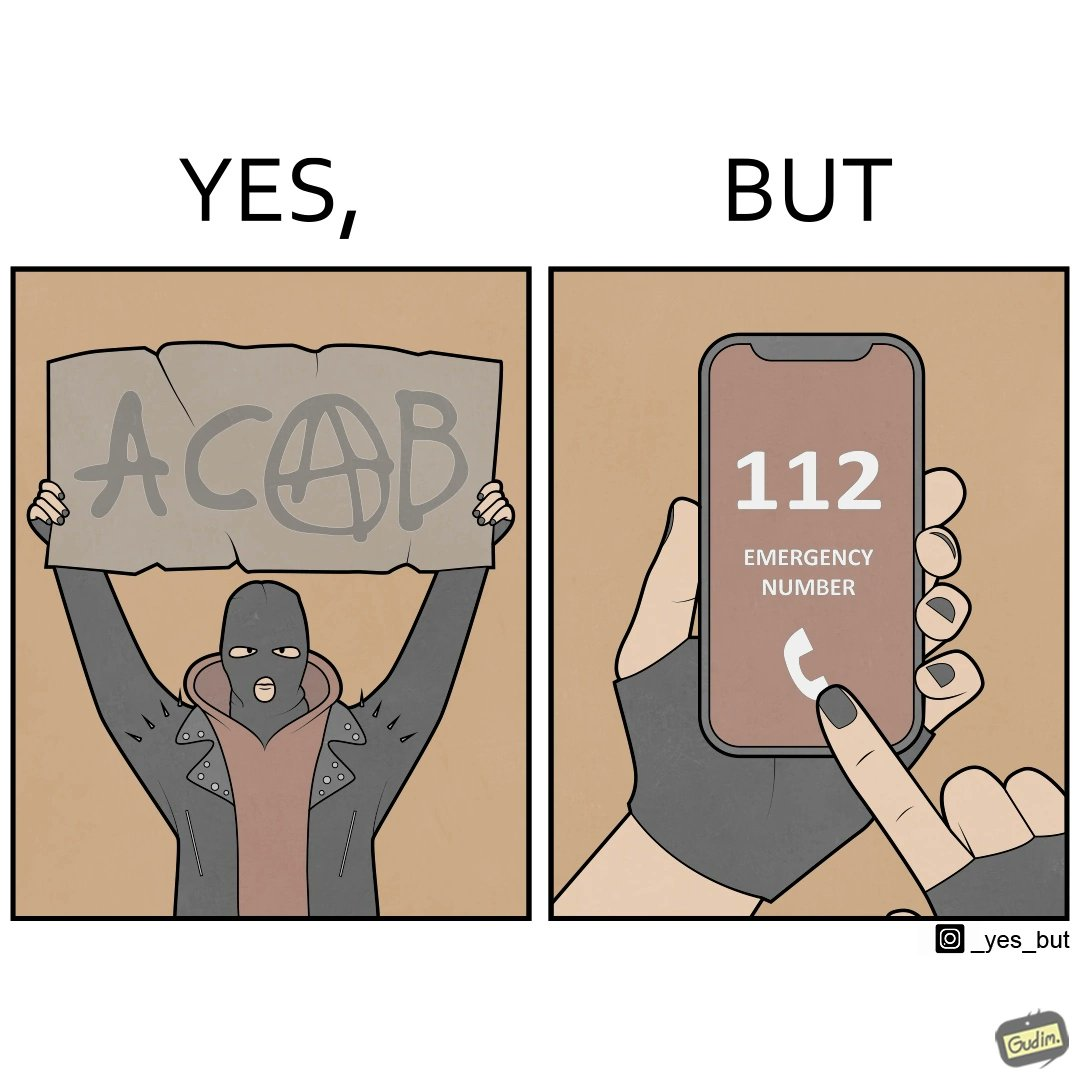Describe what you see in this image. This is funny because on the one hand this person is rebelling against cops (slogan being All Cops Are Bad - ACAB), but on the other hand they are also calling the cops for help. 